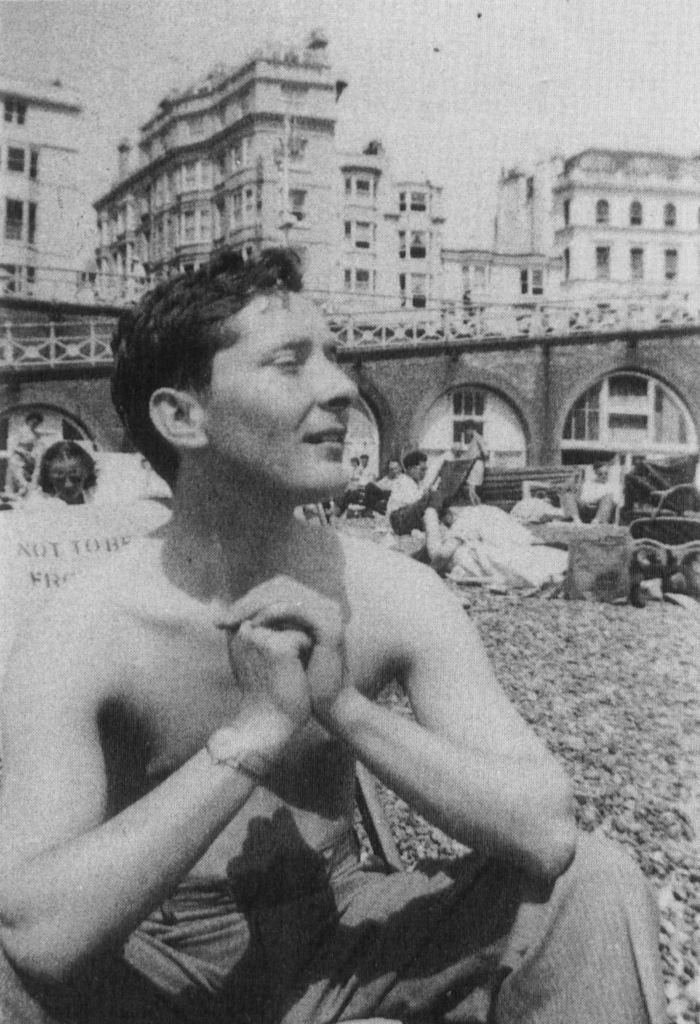Can you describe this image briefly? In this picture there is a old photograph of the man sitting on the ground, shirtless and looking to the right side. Behind we can see some more person sitting with the bags. In the background there is a arch bridge and some buildings. 